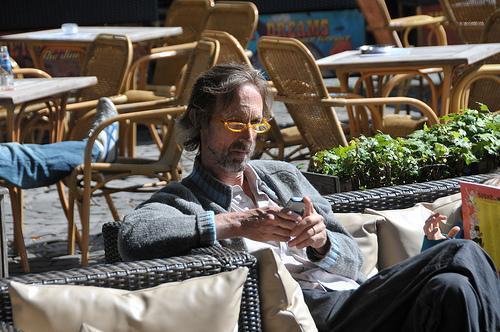How many people in picture?
Give a very brief answer. 2. How many chairs are there?
Give a very brief answer. 5. How many dining tables are visible?
Give a very brief answer. 2. How many couches can you see?
Give a very brief answer. 2. How many people can be seen?
Give a very brief answer. 2. How many white stuffed bears are there?
Give a very brief answer. 0. 